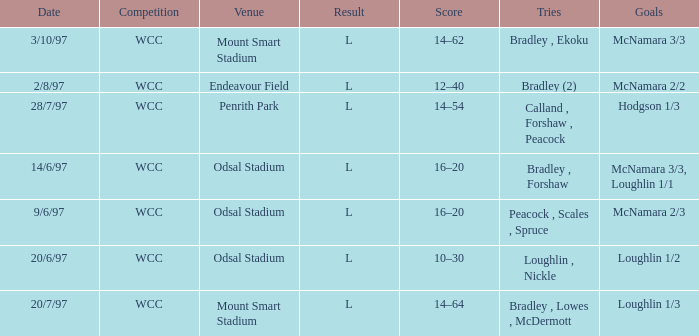What was the score on 20/6/97? 10–30. 